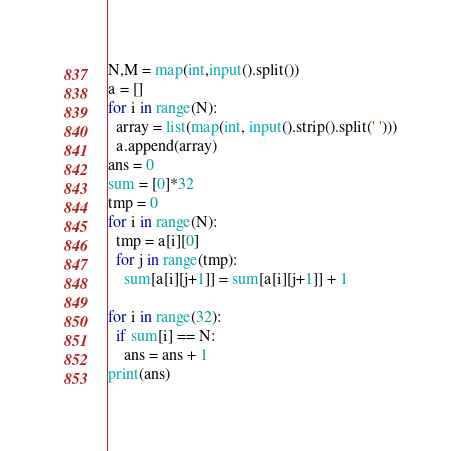<code> <loc_0><loc_0><loc_500><loc_500><_Python_>N,M = map(int,input().split())
a = []
for i in range(N):
  array = list(map(int, input().strip().split(' ')))
  a.append(array)
ans = 0
sum = [0]*32
tmp = 0
for i in range(N):
  tmp = a[i][0]
  for j in range(tmp):
    sum[a[i][j+1]] = sum[a[i][j+1]] + 1
    
for i in range(32):
  if sum[i] == N:
    ans = ans + 1
print(ans)</code> 